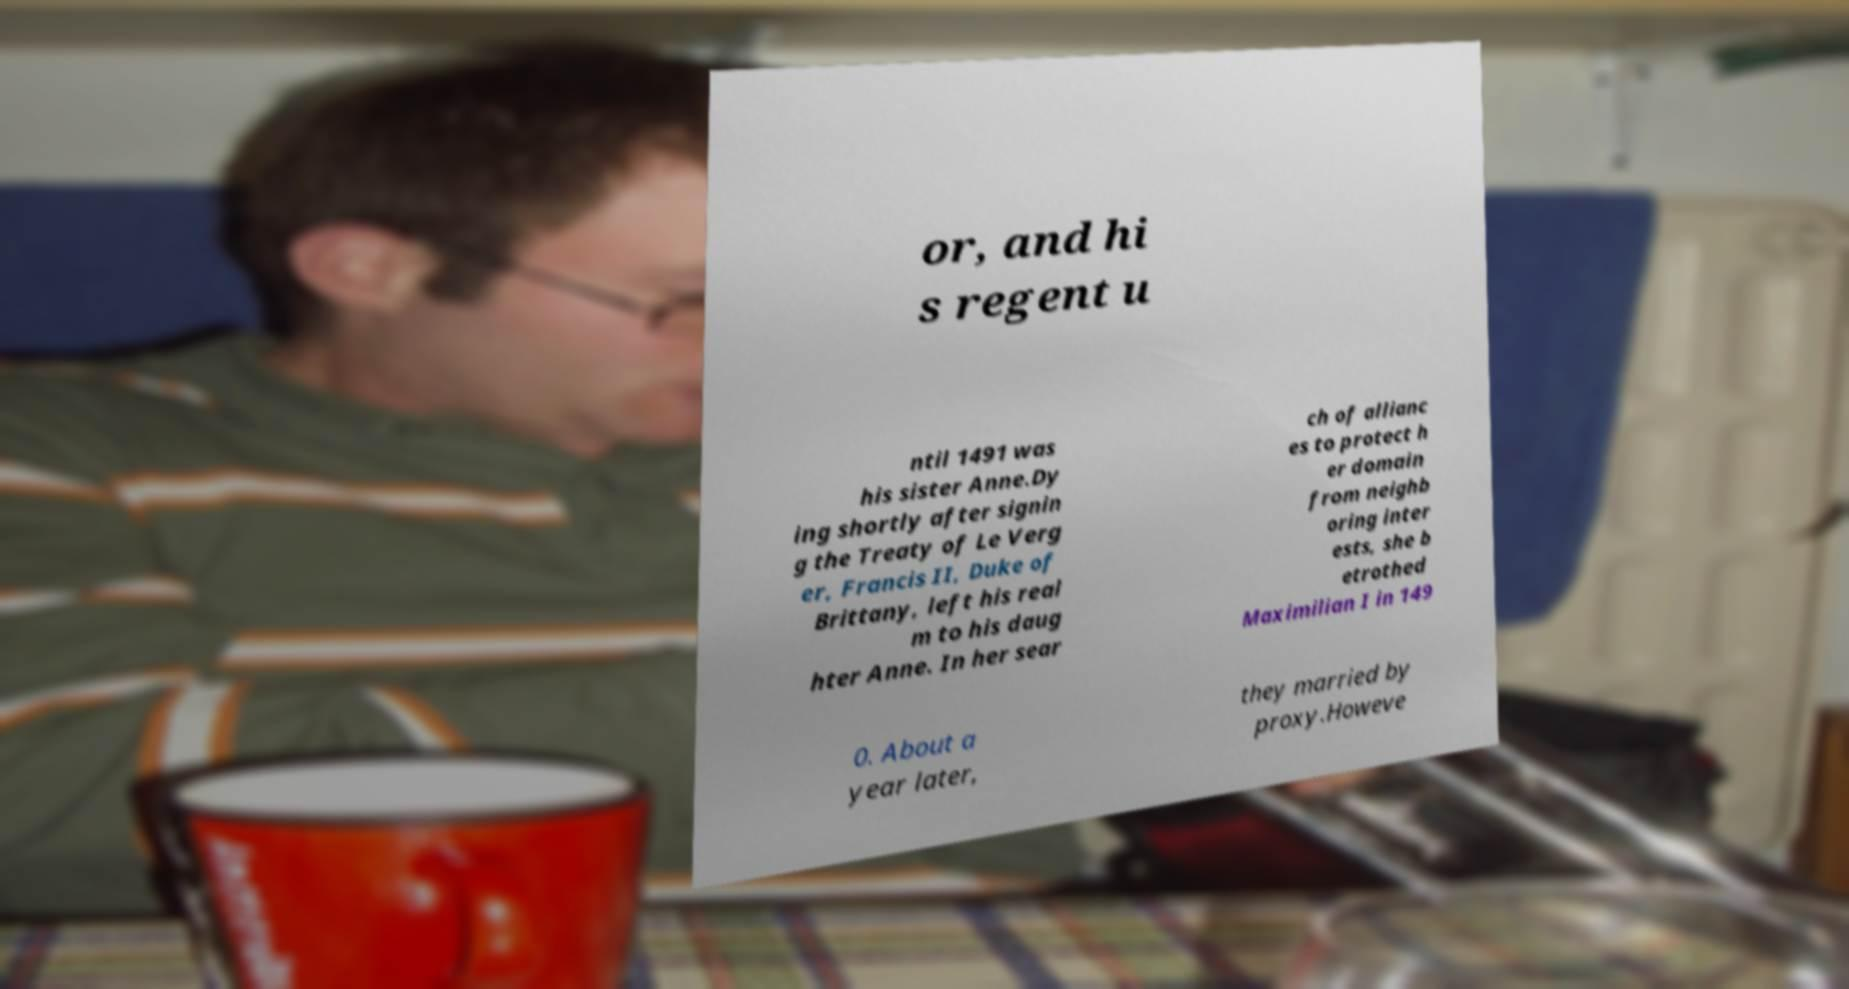Please identify and transcribe the text found in this image. or, and hi s regent u ntil 1491 was his sister Anne.Dy ing shortly after signin g the Treaty of Le Verg er, Francis II, Duke of Brittany, left his real m to his daug hter Anne. In her sear ch of allianc es to protect h er domain from neighb oring inter ests, she b etrothed Maximilian I in 149 0. About a year later, they married by proxy.Howeve 